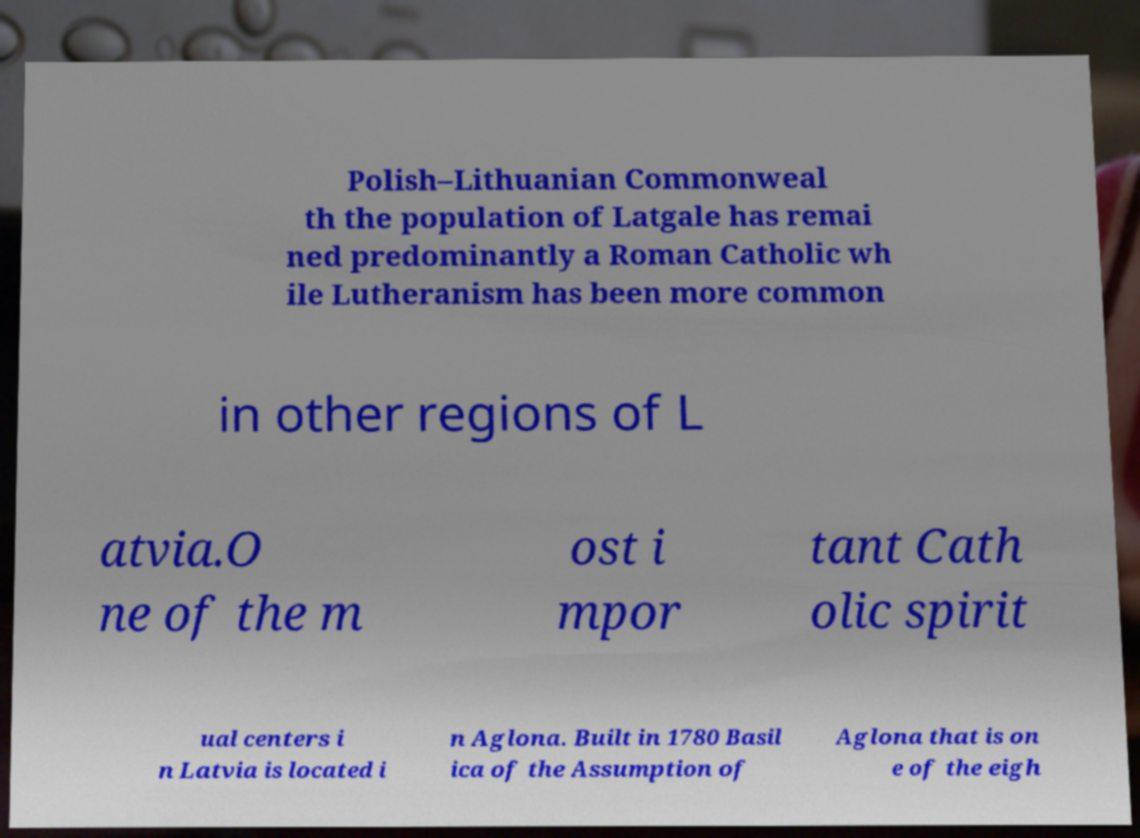There's text embedded in this image that I need extracted. Can you transcribe it verbatim? Polish–Lithuanian Commonweal th the population of Latgale has remai ned predominantly a Roman Catholic wh ile Lutheranism has been more common in other regions of L atvia.O ne of the m ost i mpor tant Cath olic spirit ual centers i n Latvia is located i n Aglona. Built in 1780 Basil ica of the Assumption of Aglona that is on e of the eigh 